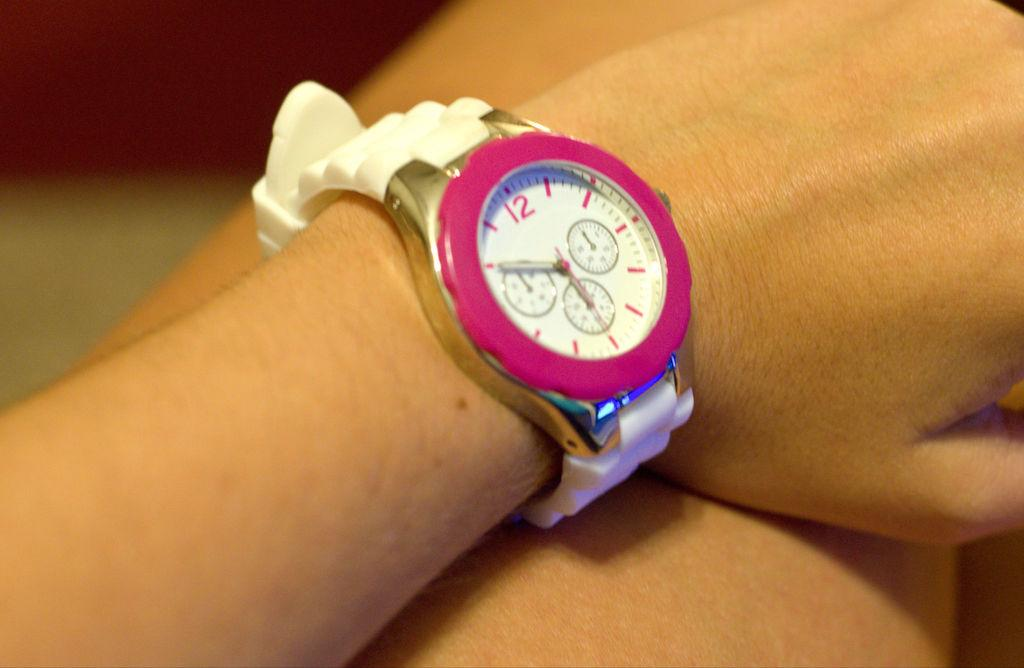<image>
Render a clear and concise summary of the photo. A watch with a white face reads almost six o'clock. 